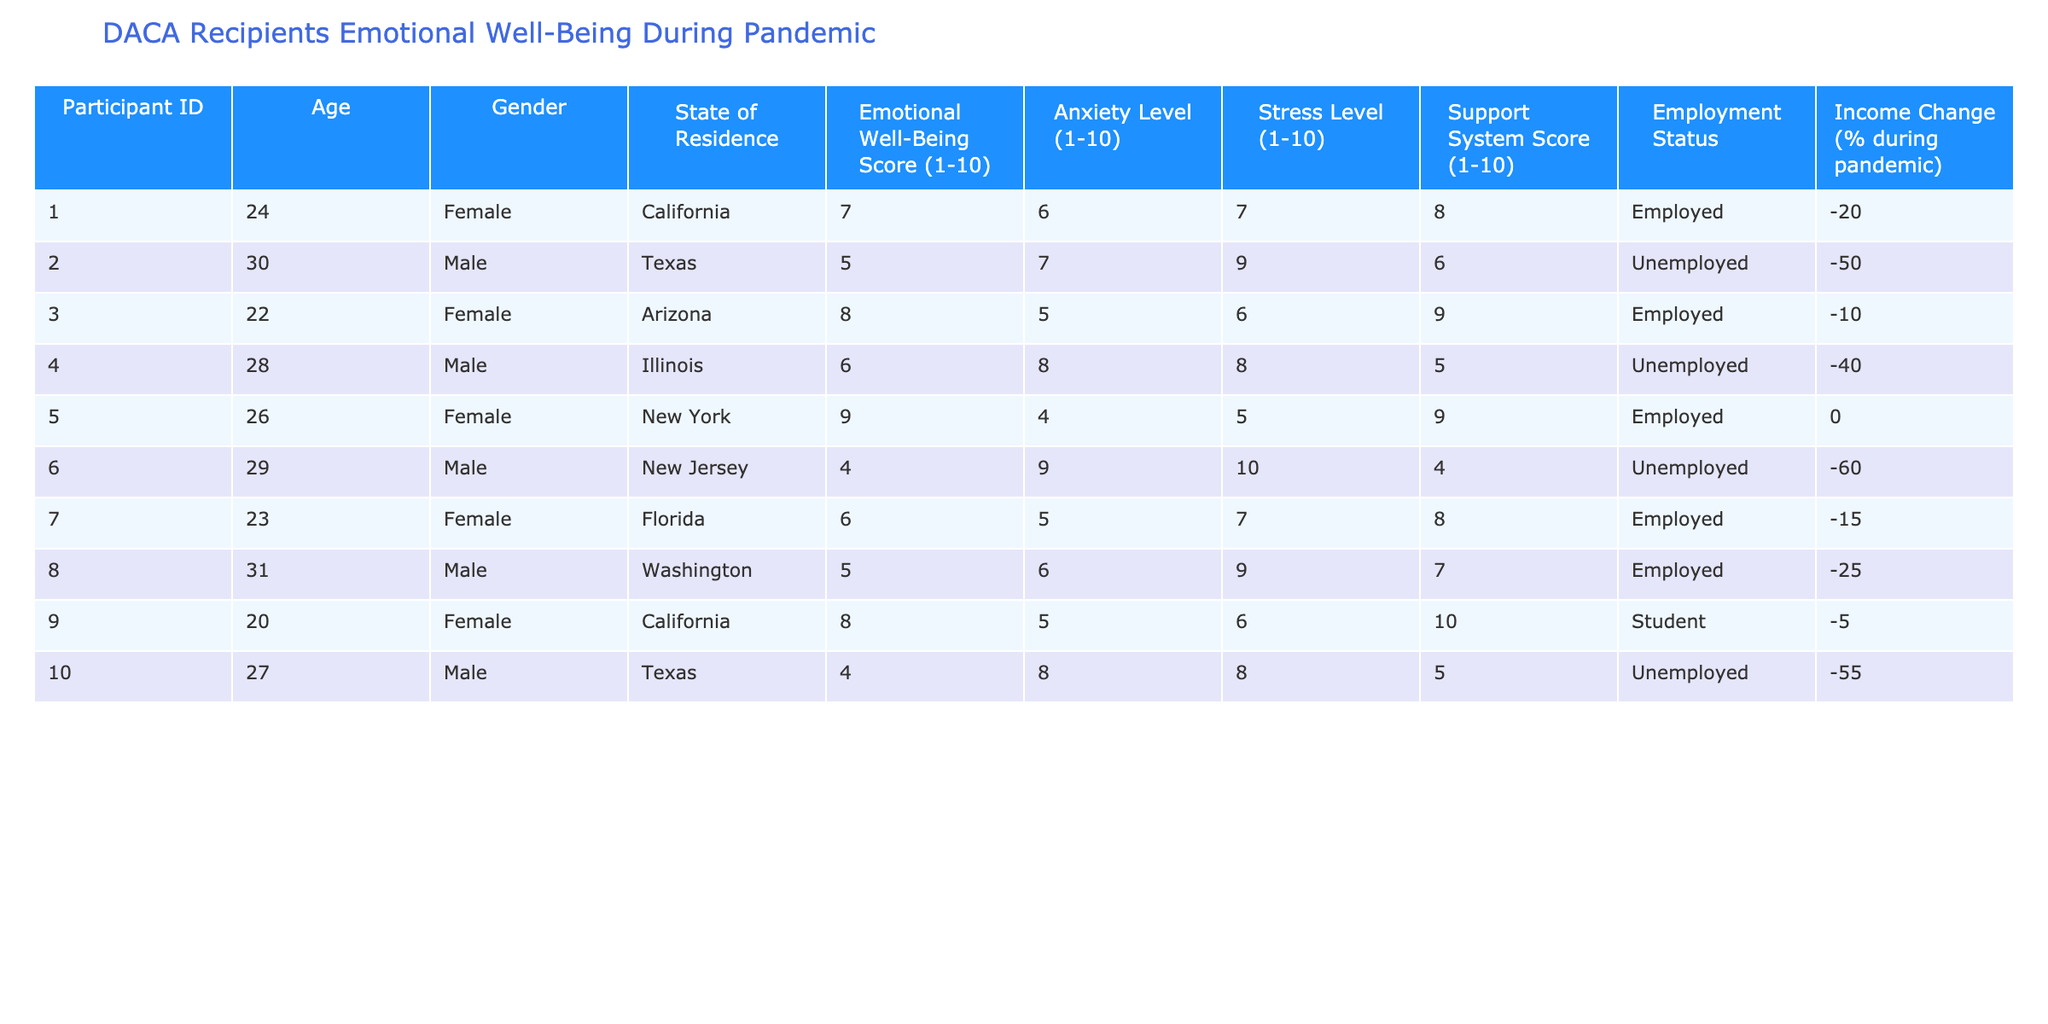What is the highest Emotional Well-Being Score among the participants? The Emotional Well-Being Score for each participant can be found in the corresponding column. By examining the scores, the highest score is 9, noted for Participant ID 5.
Answer: 9 What is the average Anxiety Level of the participants? To find the average Anxiety Level, sum the Anxiety Levels from all participants: (6 + 7 + 5 + 8 + 4 + 9 + 5 + 6 + 5 + 8) = 63. There are 10 participants, so the average is 63/10 = 6.3.
Answer: 6.3 Are there any participants with an Emotional Well-Being Score of 4 or lower? By reviewing the Emotional Well-Being Scores, only Participant ID 6 has a score of 4, while other scores are higher. Thus, there is one participant with a score at or below 4.
Answer: Yes Which participant has the lowest Support System Score, and what is that score? The Support System Scores can be accessed from the relevant column. Participant ID 6 has the lowest Support System Score of 4, compared to others.
Answer: 4 What is the total percentage of income change for all unemployed participants? Listing the income change for unemployed participants: -50, -40, -60, -55. Adding them gives (-50 - 40 - 60 - 55) = -205. Thus, the total percentage of income change for unemployed participants is -205%.
Answer: -205% What percentage of employed participants have an Emotional Well-Being Score above 6? There are 4 employed participants with scores of 7, 8, 9, and 6. Among them, 3 have scores above 6 (7, 8, 9). The percentage is (3/5) * 100 = 60%.
Answer: 60% Which state has the participant with the highest Stress Level, and what is that level? Evaluating the Stress Levels from the table, Participant ID 6 in New Jersey has the highest Stress Level of 10.
Answer: New Jersey, 10 Is there any participant living in California who has a Support System Score of less than 8? Examining the participants from California, Participant ID 1 has a Support System Score of 8 and Participant ID 9 has a score of 10. Therefore, no participant from California has a score less than 8.
Answer: No 